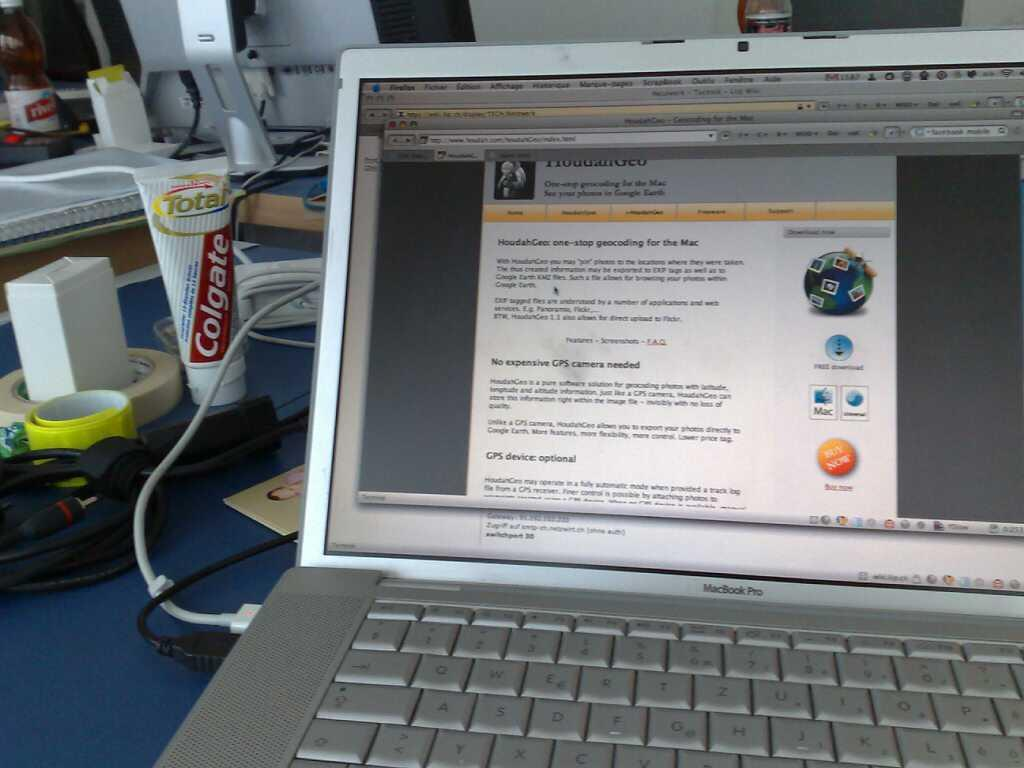<image>
Present a compact description of the photo's key features. A tube of Colgate next to an open laptop. 